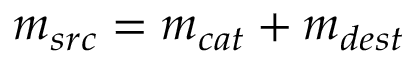<formula> <loc_0><loc_0><loc_500><loc_500>m _ { s r c } = m _ { c a t } + m _ { d e s t }</formula> 